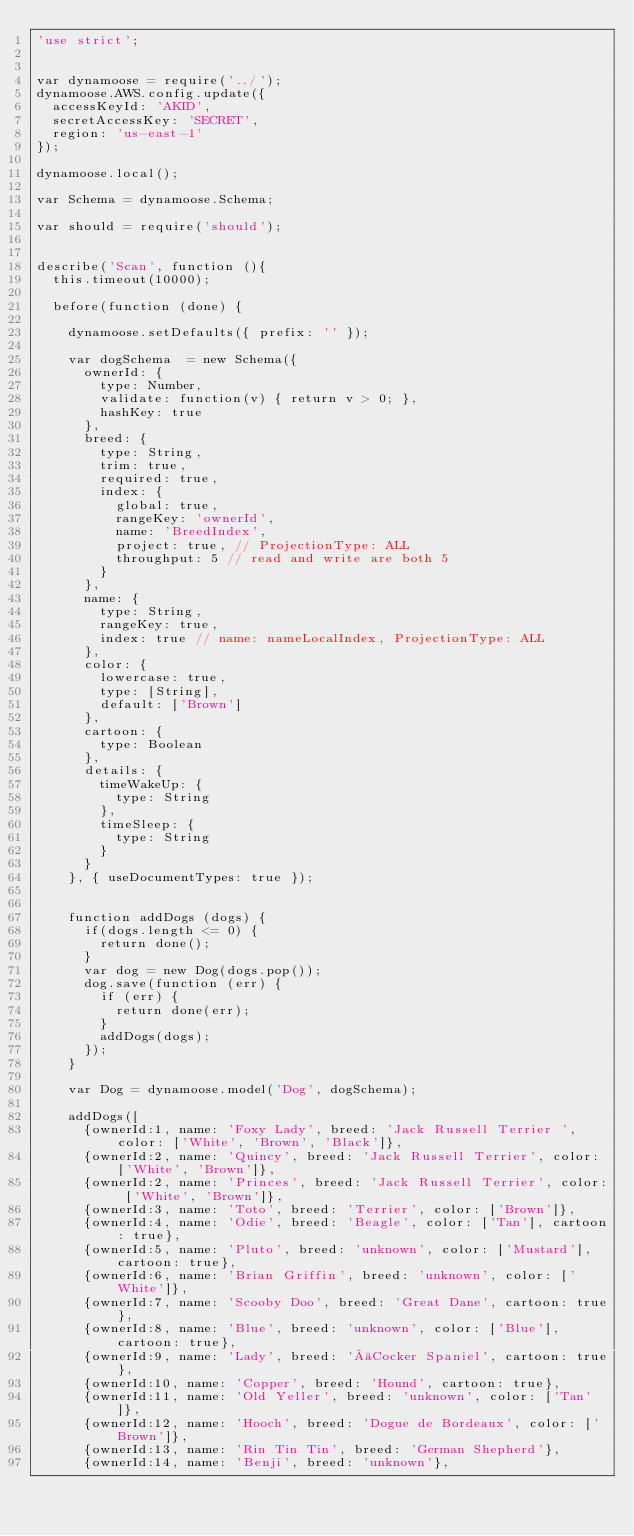Convert code to text. <code><loc_0><loc_0><loc_500><loc_500><_JavaScript_>'use strict';


var dynamoose = require('../');
dynamoose.AWS.config.update({
  accessKeyId: 'AKID',
  secretAccessKey: 'SECRET',
  region: 'us-east-1'
});

dynamoose.local();

var Schema = dynamoose.Schema;

var should = require('should');


describe('Scan', function (){
  this.timeout(10000);

  before(function (done) {

    dynamoose.setDefaults({ prefix: '' });

    var dogSchema  = new Schema({
      ownerId: {
        type: Number,
        validate: function(v) { return v > 0; },
        hashKey: true
      },
      breed: {
        type: String,
        trim: true,
        required: true,
        index: {
          global: true,
          rangeKey: 'ownerId',
          name: 'BreedIndex',
          project: true, // ProjectionType: ALL
          throughput: 5 // read and write are both 5
        }
      },
      name: {
        type: String,
        rangeKey: true,
        index: true // name: nameLocalIndex, ProjectionType: ALL
      },
      color: {
        lowercase: true,
        type: [String],
        default: ['Brown']
      },
      cartoon: {
        type: Boolean
      },
      details: {
        timeWakeUp: {
          type: String
        },
        timeSleep: {
          type: String
        }
      }
    }, { useDocumentTypes: true });


    function addDogs (dogs) {
      if(dogs.length <= 0) {
        return done();
      }
      var dog = new Dog(dogs.pop());
      dog.save(function (err) {
        if (err) {
          return done(err);
        }
        addDogs(dogs);
      });
    }

    var Dog = dynamoose.model('Dog', dogSchema);

    addDogs([
      {ownerId:1, name: 'Foxy Lady', breed: 'Jack Russell Terrier ', color: ['White', 'Brown', 'Black']},
      {ownerId:2, name: 'Quincy', breed: 'Jack Russell Terrier', color: ['White', 'Brown']},
      {ownerId:2, name: 'Princes', breed: 'Jack Russell Terrier', color: ['White', 'Brown']},
      {ownerId:3, name: 'Toto', breed: 'Terrier', color: ['Brown']},
      {ownerId:4, name: 'Odie', breed: 'Beagle', color: ['Tan'], cartoon: true},
      {ownerId:5, name: 'Pluto', breed: 'unknown', color: ['Mustard'], cartoon: true},
      {ownerId:6, name: 'Brian Griffin', breed: 'unknown', color: ['White']},
      {ownerId:7, name: 'Scooby Doo', breed: 'Great Dane', cartoon: true},
      {ownerId:8, name: 'Blue', breed: 'unknown', color: ['Blue'], cartoon: true},
      {ownerId:9, name: 'Lady', breed: ' Cocker Spaniel', cartoon: true},
      {ownerId:10, name: 'Copper', breed: 'Hound', cartoon: true},
      {ownerId:11, name: 'Old Yeller', breed: 'unknown', color: ['Tan']},
      {ownerId:12, name: 'Hooch', breed: 'Dogue de Bordeaux', color: ['Brown']},
      {ownerId:13, name: 'Rin Tin Tin', breed: 'German Shepherd'},
      {ownerId:14, name: 'Benji', breed: 'unknown'},</code> 